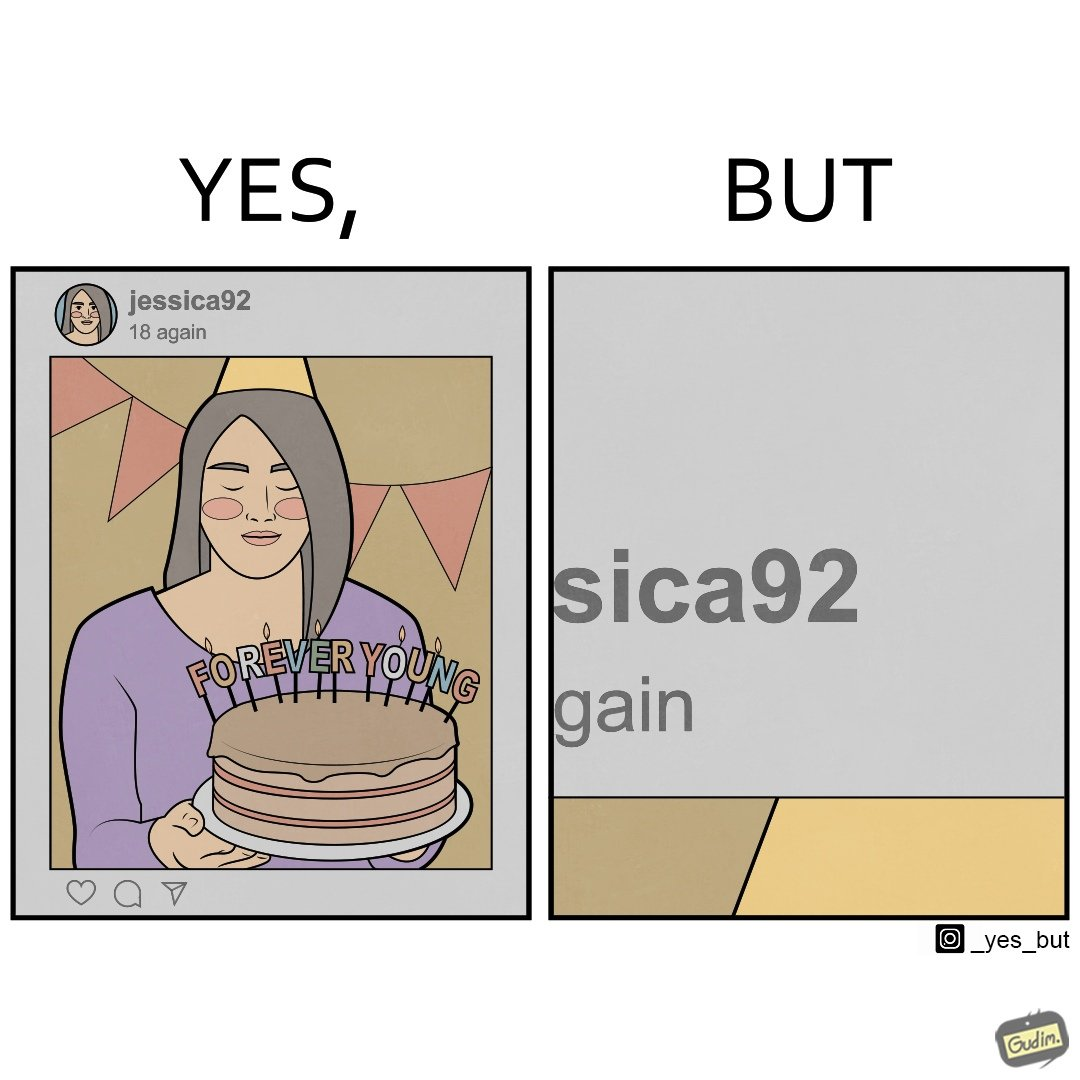Is there satirical content in this image? Yes, this image is satirical. 